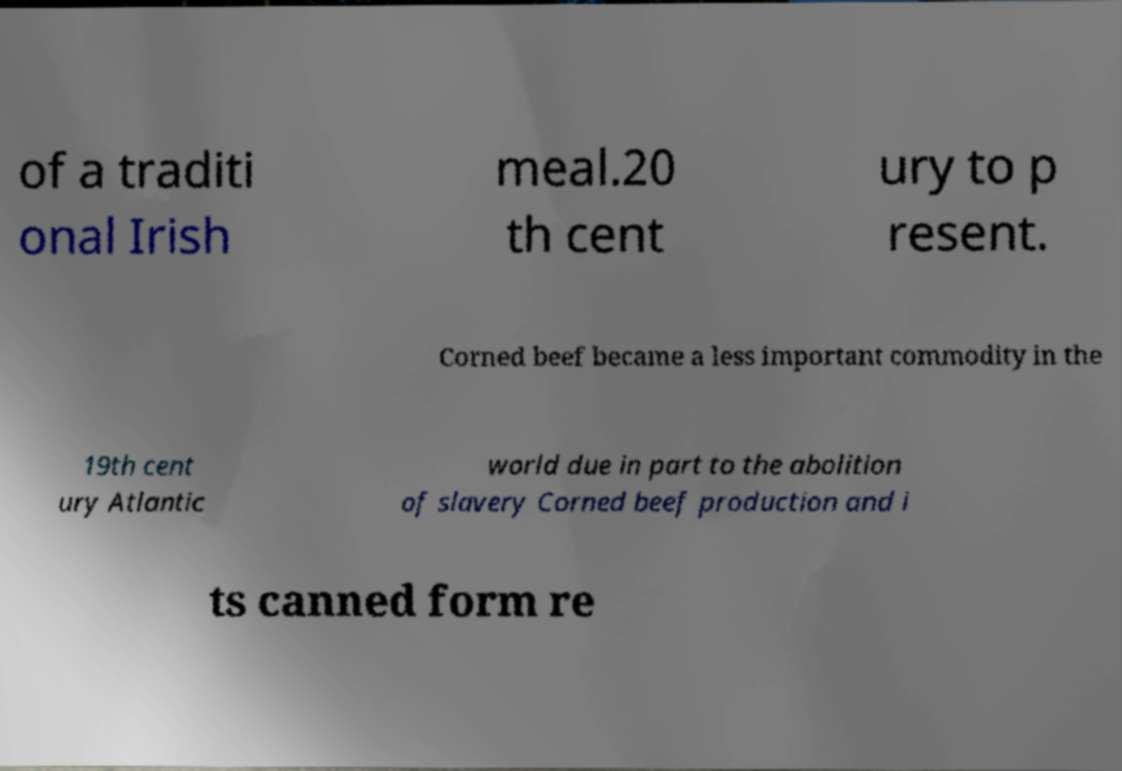Please read and relay the text visible in this image. What does it say? of a traditi onal Irish meal.20 th cent ury to p resent. Corned beef became a less important commodity in the 19th cent ury Atlantic world due in part to the abolition of slavery Corned beef production and i ts canned form re 